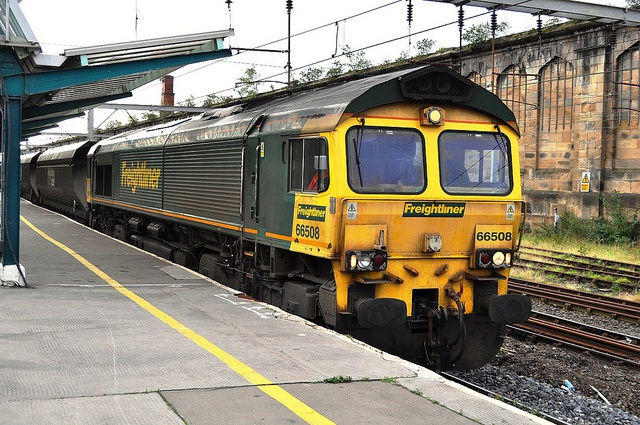Describe the objects in this image and their specific colors. I can see train in gray, black, orange, and darkgray tones and people in gray, maroon, black, and brown tones in this image. 